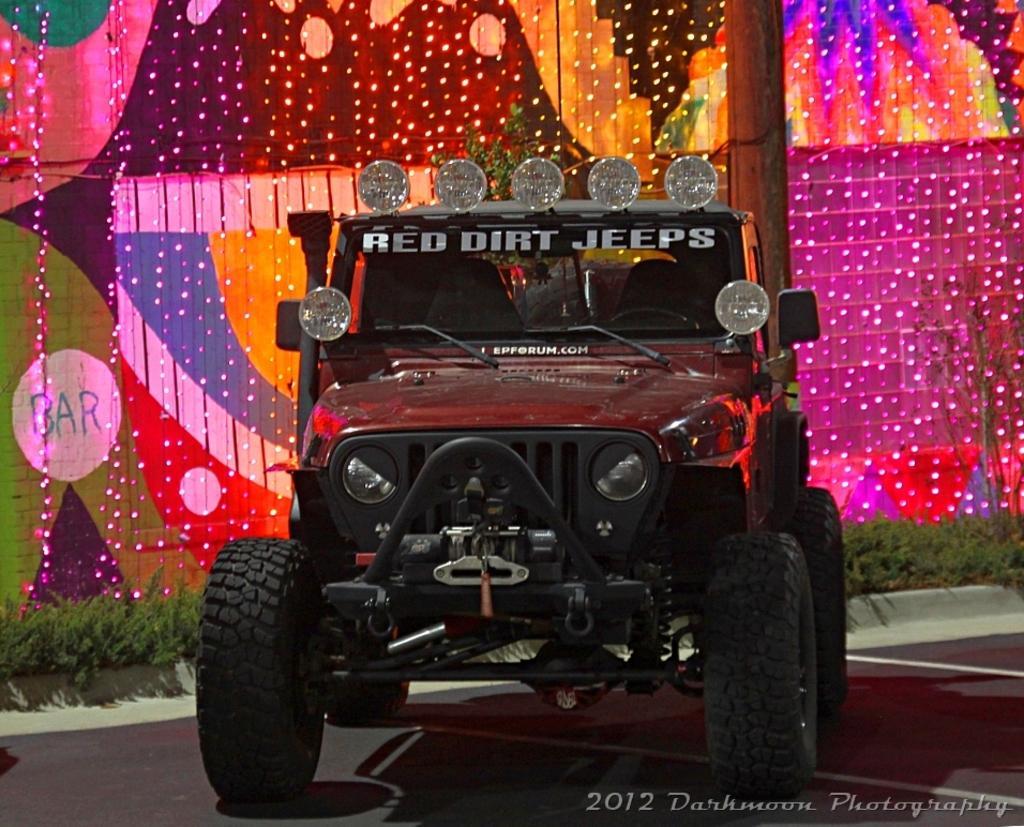Describe this image in one or two sentences. In the image there is a jeep in the foreground, behind the jeep there are plants and many lights. 